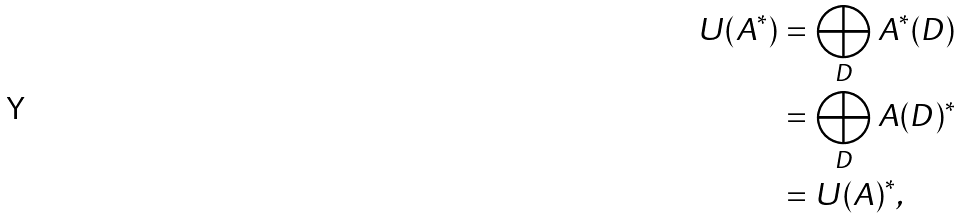<formula> <loc_0><loc_0><loc_500><loc_500>U ( A ^ { * } ) & = \bigoplus _ { D } A ^ { * } ( D ) \\ & = \bigoplus _ { D } A ( D ) ^ { * } \\ & = U ( A ) ^ { * } ,</formula> 